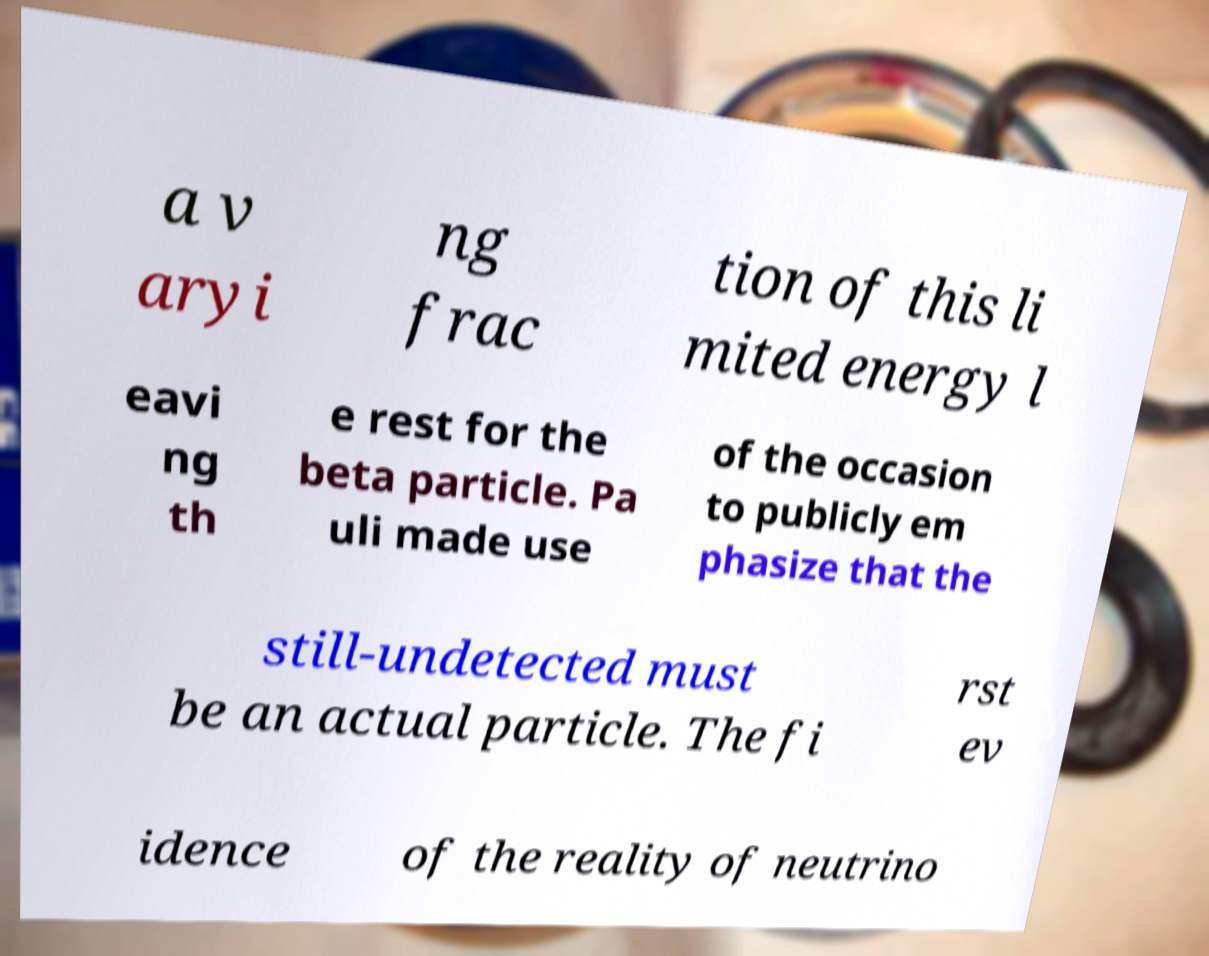Could you extract and type out the text from this image? a v aryi ng frac tion of this li mited energy l eavi ng th e rest for the beta particle. Pa uli made use of the occasion to publicly em phasize that the still-undetected must be an actual particle. The fi rst ev idence of the reality of neutrino 